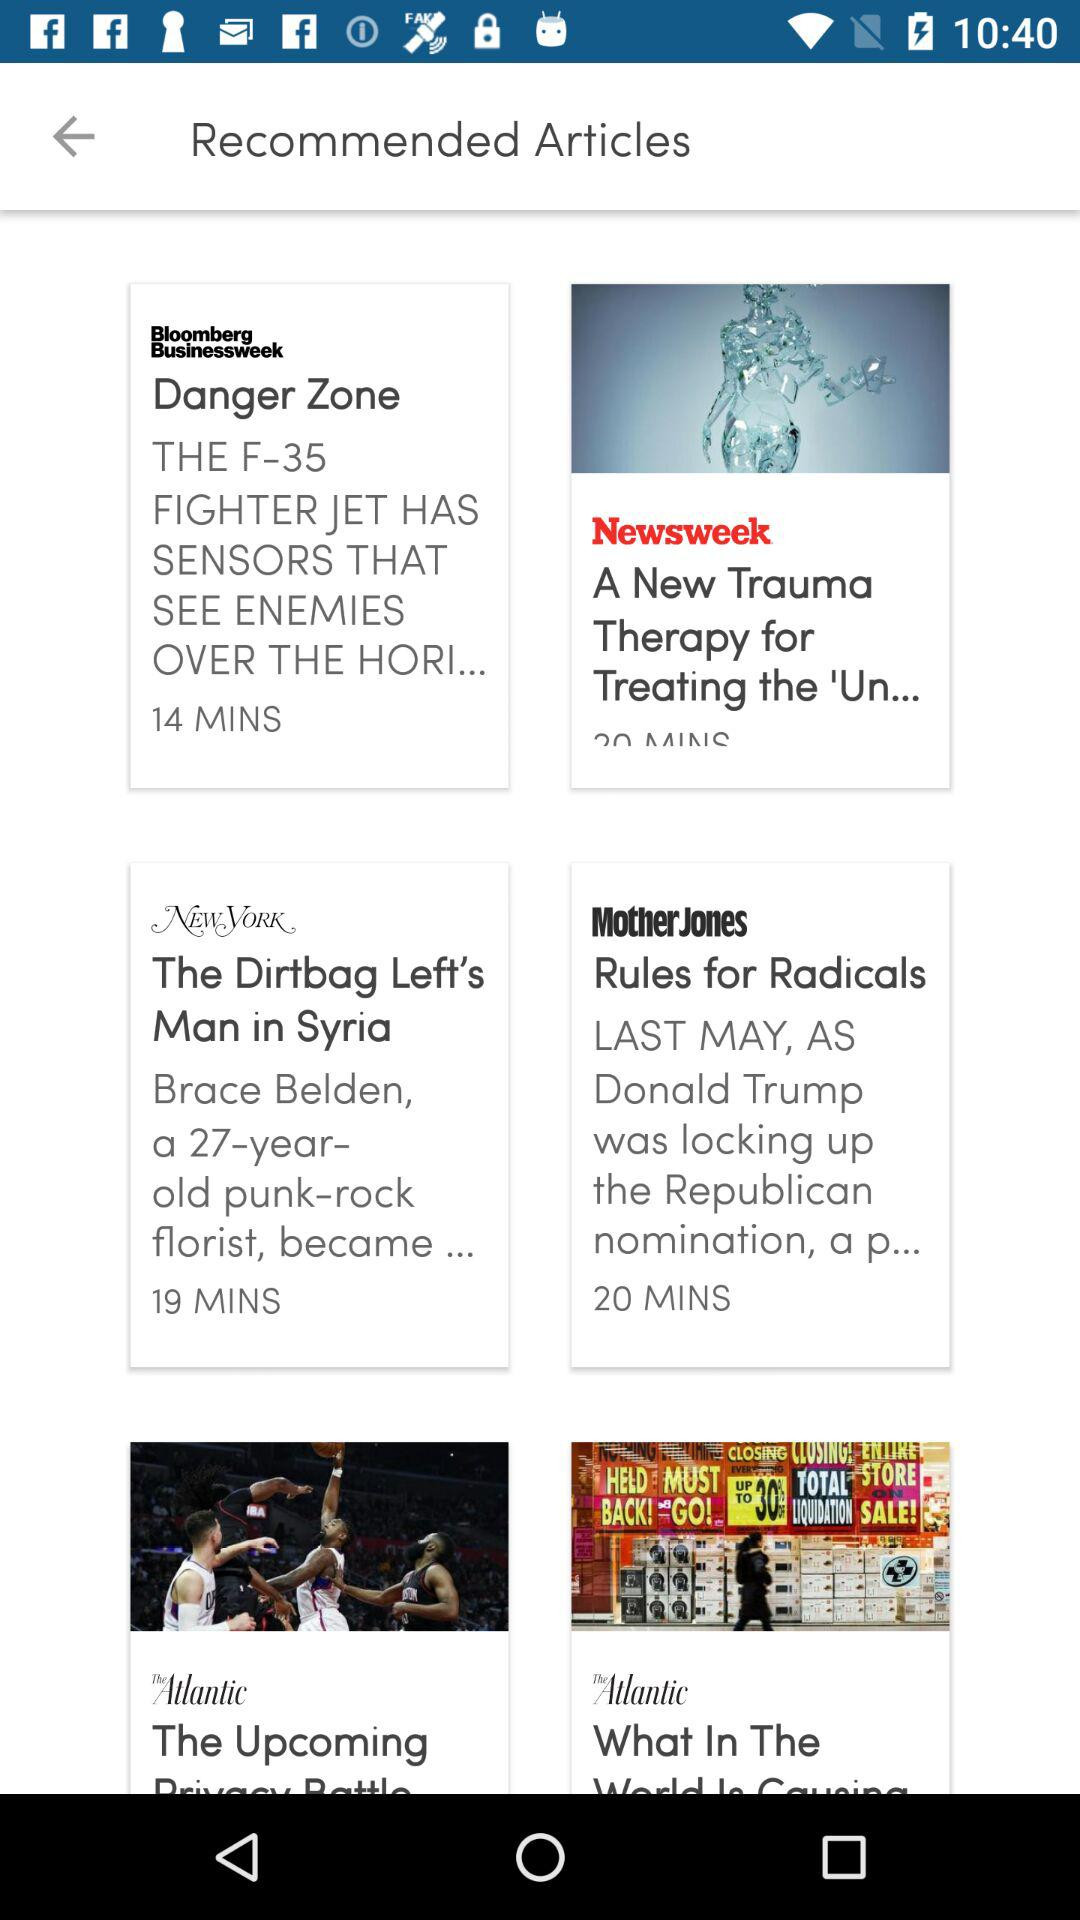How many minutes ago was the "Danger Zone" article published? The "Danger Zone" article was published 14 minutes ago. 